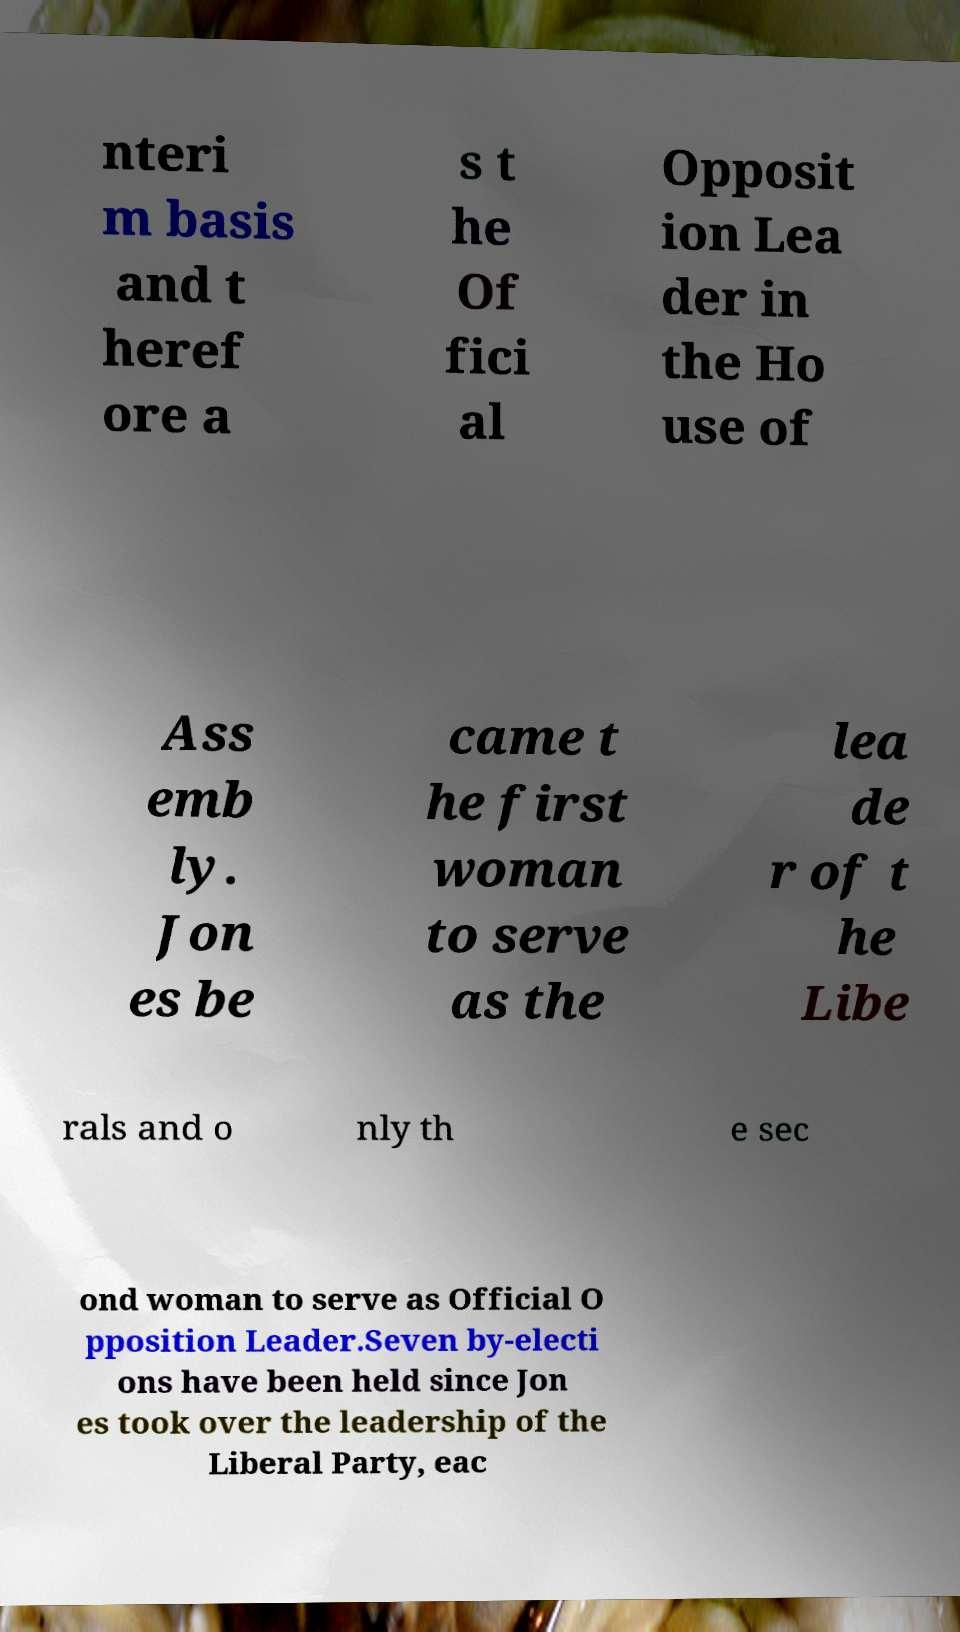There's text embedded in this image that I need extracted. Can you transcribe it verbatim? nteri m basis and t heref ore a s t he Of fici al Opposit ion Lea der in the Ho use of Ass emb ly. Jon es be came t he first woman to serve as the lea de r of t he Libe rals and o nly th e sec ond woman to serve as Official O pposition Leader.Seven by-electi ons have been held since Jon es took over the leadership of the Liberal Party, eac 